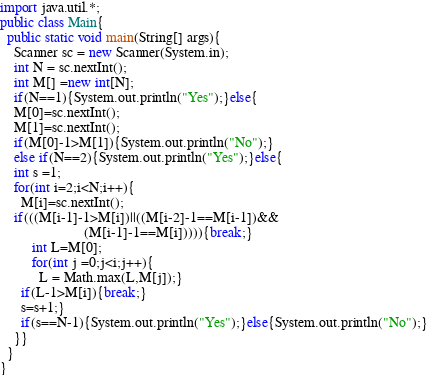Convert code to text. <code><loc_0><loc_0><loc_500><loc_500><_Java_>import java.util.*;
public class Main{
  public static void main(String[] args){
    Scanner sc = new Scanner(System.in);
    int N = sc.nextInt();
    int M[] =new int[N];
    if(N==1){System.out.println("Yes");}else{
    M[0]=sc.nextInt();
    M[1]=sc.nextInt();
    if(M[0]-1>M[1]){System.out.println("No");}
    else if(N==2){System.out.println("Yes");}else{
    int s =1;
    for(int i=2;i<N;i++){
      M[i]=sc.nextInt();
    if(((M[i-1]-1>M[i])||((M[i-2]-1==M[i-1])&&
                        (M[i-1]-1==M[i])))){break;}
         int L=M[0];
         for(int j =0;j<i;j++){
           L = Math.max(L,M[j]);}
      if(L-1>M[i]){break;}
      s=s+1;}
      if(s==N-1){System.out.println("Yes");}else{System.out.println("No");}
    }}
  }
}
</code> 